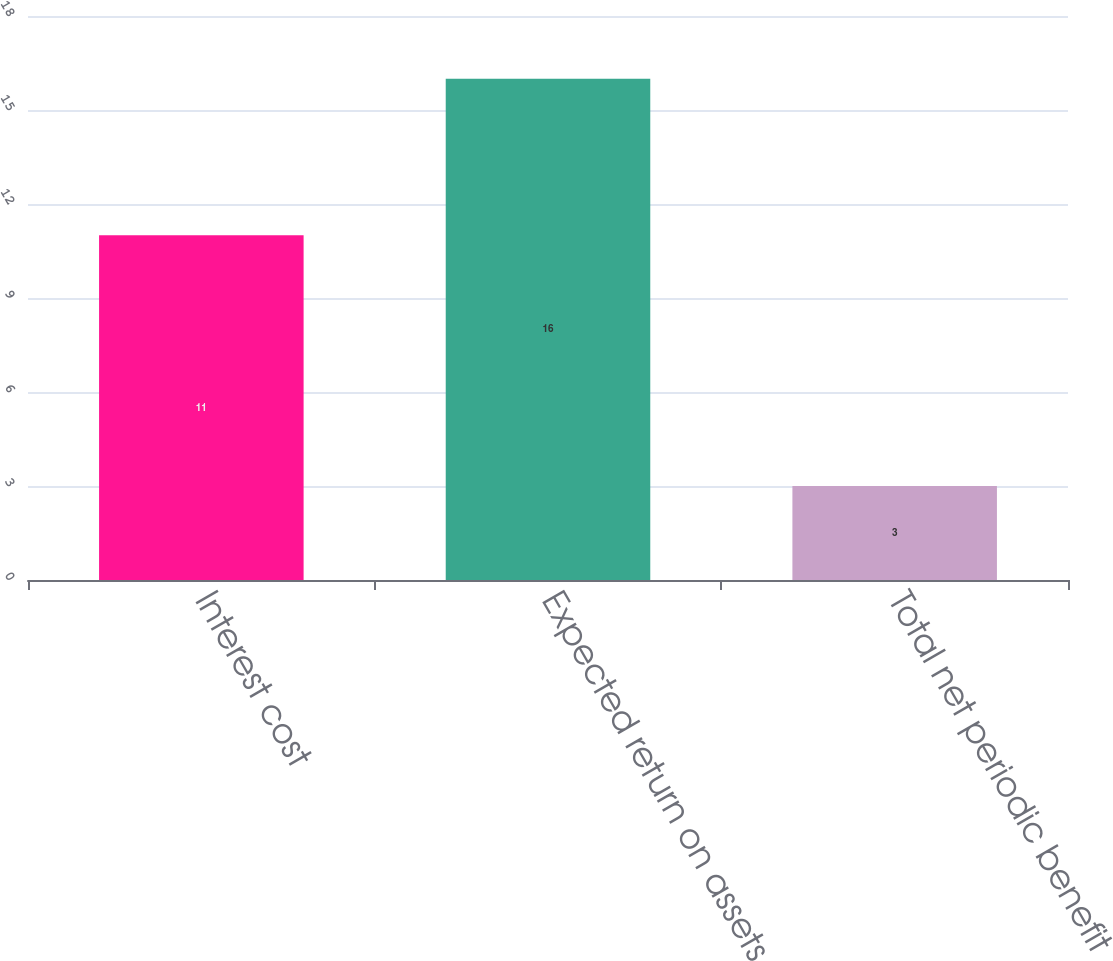Convert chart. <chart><loc_0><loc_0><loc_500><loc_500><bar_chart><fcel>Interest cost<fcel>Expected return on assets<fcel>Total net periodic benefit<nl><fcel>11<fcel>16<fcel>3<nl></chart> 